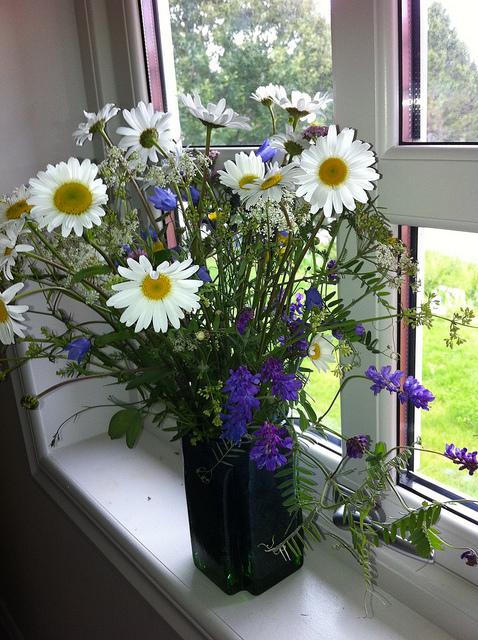Is the window transparent?
Short answer required. Yes. Where are the flowers?
Quick response, please. Window. How many different flowers are in the vase?
Be succinct. 2. 